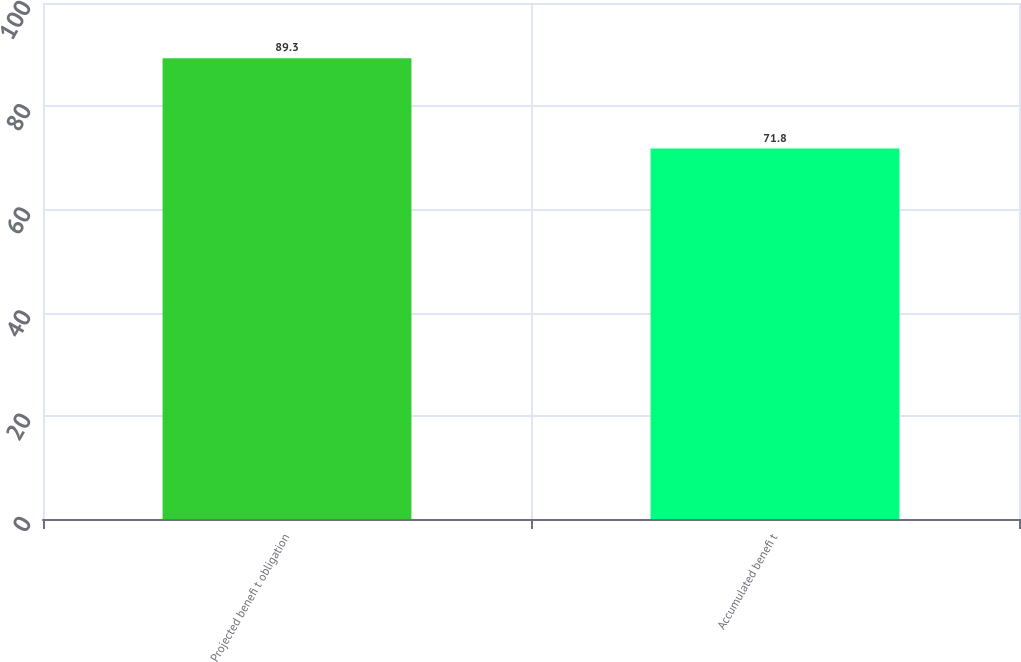Convert chart to OTSL. <chart><loc_0><loc_0><loc_500><loc_500><bar_chart><fcel>Projected benefi t obligation<fcel>Accumulated benefi t<nl><fcel>89.3<fcel>71.8<nl></chart> 